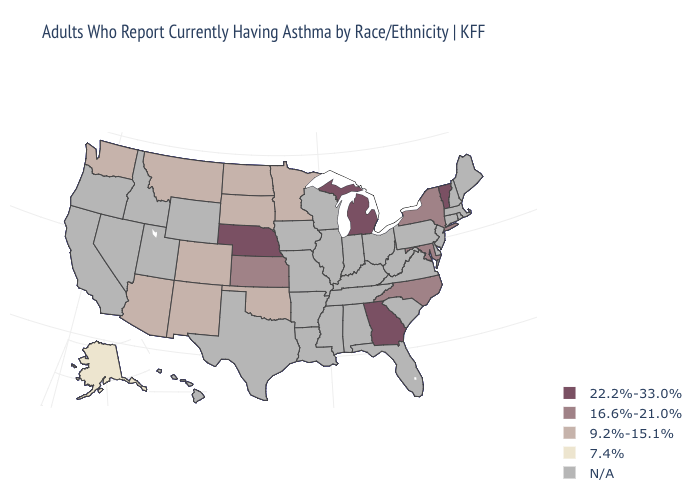What is the highest value in the Northeast ?
Concise answer only. 22.2%-33.0%. Among the states that border North Carolina , which have the lowest value?
Answer briefly. Georgia. Does Vermont have the lowest value in the Northeast?
Answer briefly. No. What is the lowest value in states that border Montana?
Concise answer only. 9.2%-15.1%. Which states hav the highest value in the Northeast?
Quick response, please. Vermont. Is the legend a continuous bar?
Concise answer only. No. What is the lowest value in states that border Kansas?
Give a very brief answer. 9.2%-15.1%. Which states have the lowest value in the MidWest?
Concise answer only. Minnesota, North Dakota, South Dakota. What is the value of Montana?
Write a very short answer. 9.2%-15.1%. What is the highest value in states that border Tennessee?
Quick response, please. 22.2%-33.0%. Which states hav the highest value in the West?
Answer briefly. Arizona, Colorado, Montana, New Mexico, Washington. Which states have the highest value in the USA?
Give a very brief answer. Georgia, Michigan, Nebraska, Vermont. What is the highest value in the MidWest ?
Give a very brief answer. 22.2%-33.0%. 